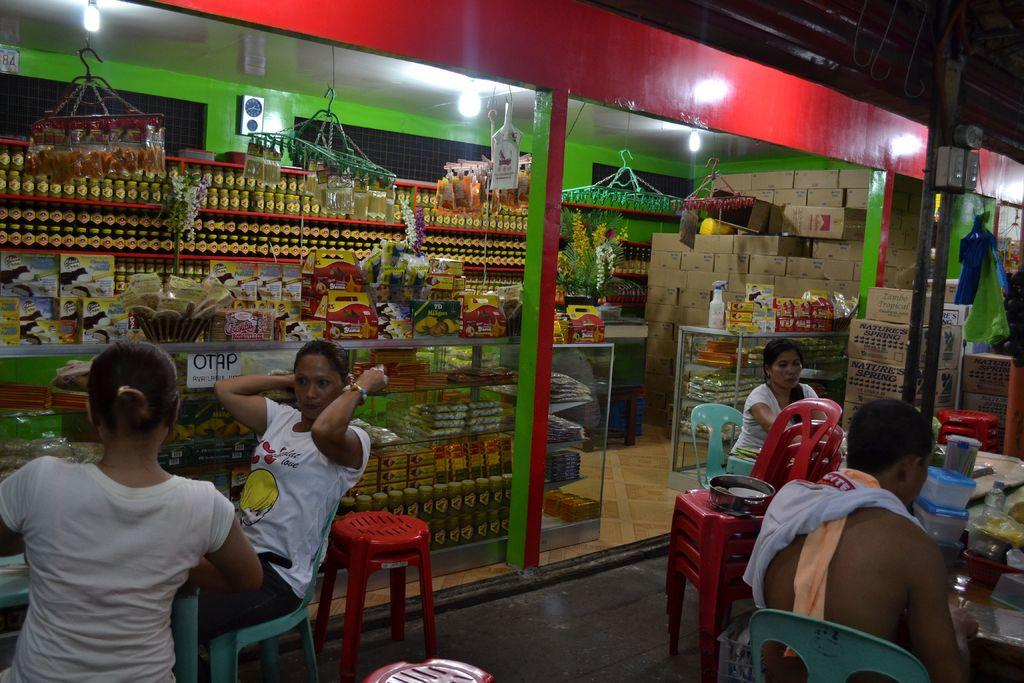How many people are in the image? There are four people in the image. What are the people doing in the image? The people are sitting in chairs. Where are the chairs located in relation to the store? The chairs are in front of a store. What type of boats can be seen in the image? There are no boats present in the image. 